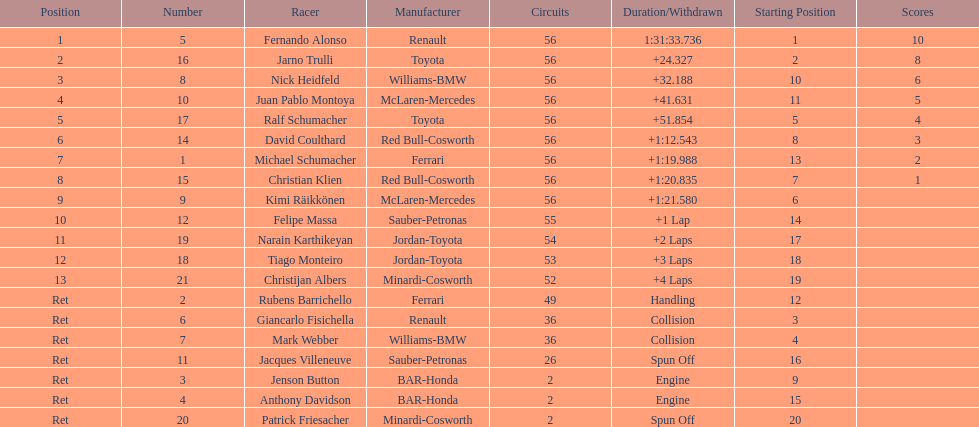How many drivers were retired before the race could end? 7. 